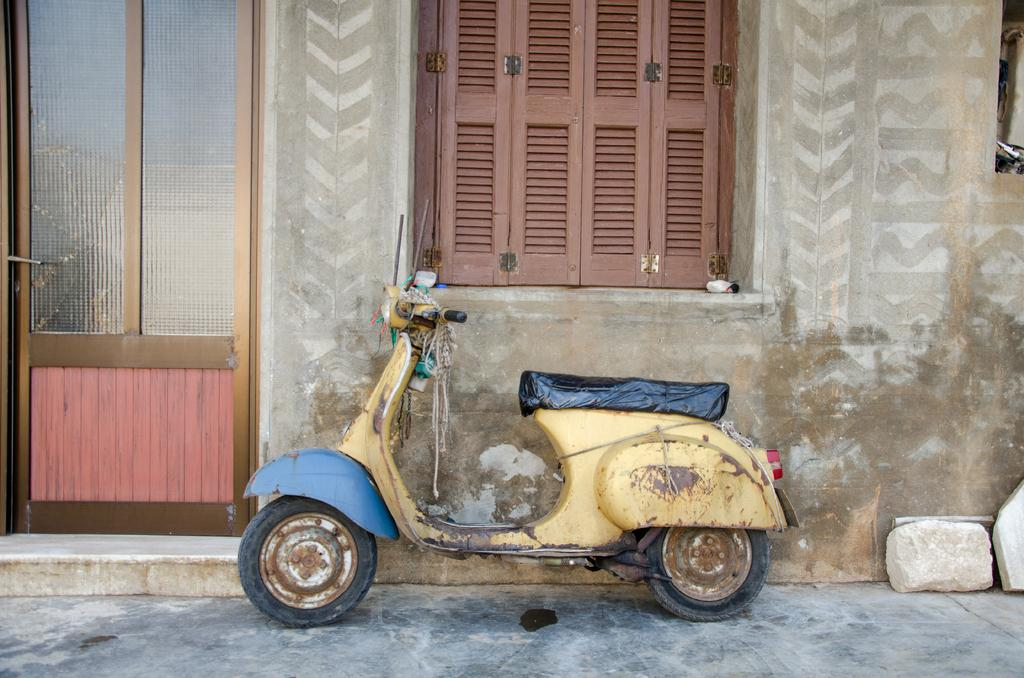What type of vehicle is in the image? There is a yellow scooter in the image. Where is the scooter located? The scooter is parked on a path. What is the scooter's proximity to a house? The scooter is near a house wall. What architectural features can be seen in the image? There is a window and a door visible in the image. What is on the floor in the image? There are rocks on the floor in the image. What type of skirt is hanging on the door in the image? There is no skirt present in the image; only a window and a door are visible. 